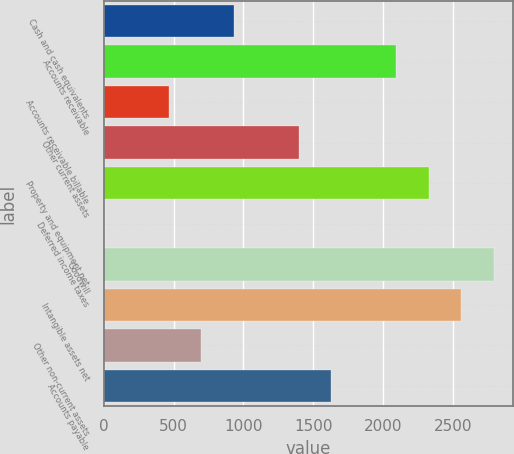Convert chart to OTSL. <chart><loc_0><loc_0><loc_500><loc_500><bar_chart><fcel>Cash and cash equivalents<fcel>Accounts receivable<fcel>Accounts receivable billable<fcel>Other current assets<fcel>Property and equipment net<fcel>Deferred income taxes<fcel>Goodwill<fcel>Intangible assets net<fcel>Other non-current assets<fcel>Accounts payable<nl><fcel>931.52<fcel>2095.17<fcel>466.06<fcel>1396.98<fcel>2327.9<fcel>0.6<fcel>2793.36<fcel>2560.63<fcel>698.79<fcel>1629.71<nl></chart> 